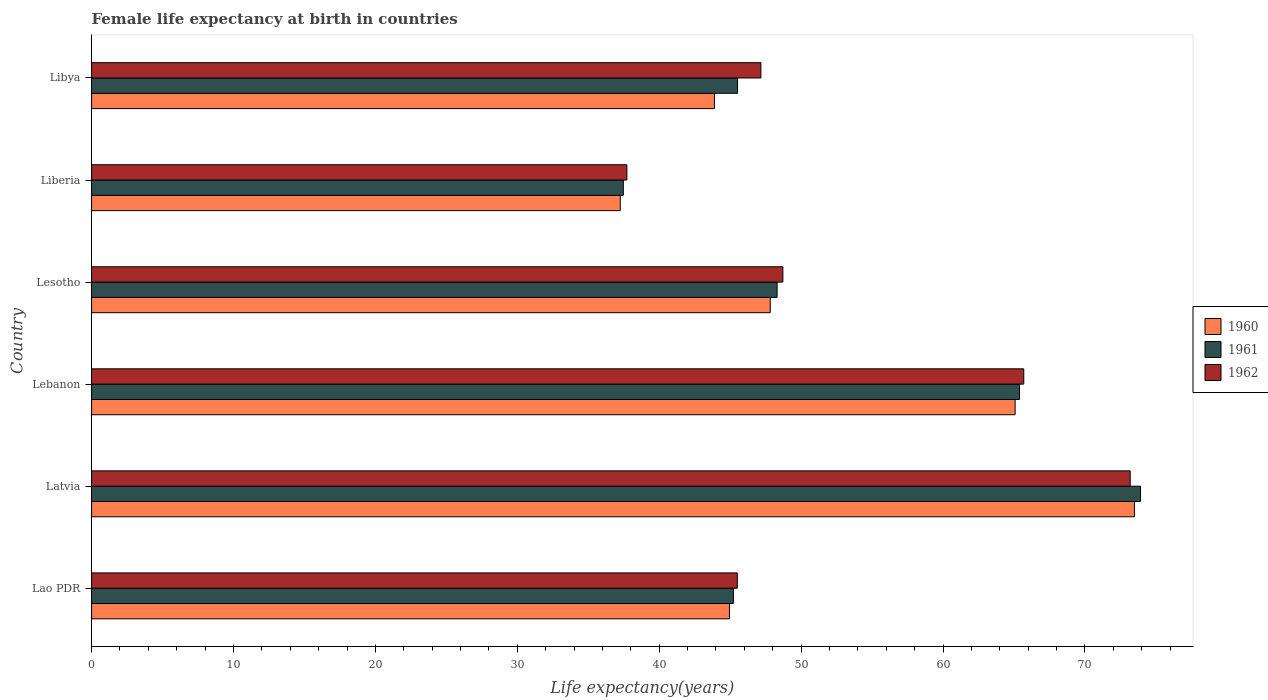Are the number of bars per tick equal to the number of legend labels?
Ensure brevity in your answer.  Yes. How many bars are there on the 3rd tick from the top?
Your answer should be very brief. 3. What is the label of the 1st group of bars from the top?
Offer a terse response. Libya. In how many cases, is the number of bars for a given country not equal to the number of legend labels?
Your answer should be compact. 0. What is the female life expectancy at birth in 1960 in Liberia?
Your answer should be compact. 37.25. Across all countries, what is the maximum female life expectancy at birth in 1960?
Offer a very short reply. 73.49. Across all countries, what is the minimum female life expectancy at birth in 1961?
Provide a succinct answer. 37.47. In which country was the female life expectancy at birth in 1962 maximum?
Provide a succinct answer. Latvia. In which country was the female life expectancy at birth in 1961 minimum?
Keep it short and to the point. Liberia. What is the total female life expectancy at birth in 1962 in the graph?
Ensure brevity in your answer.  317.99. What is the difference between the female life expectancy at birth in 1960 in Latvia and that in Lesotho?
Ensure brevity in your answer.  25.66. What is the difference between the female life expectancy at birth in 1962 in Lesotho and the female life expectancy at birth in 1961 in Lebanon?
Give a very brief answer. -16.68. What is the average female life expectancy at birth in 1962 per country?
Provide a succinct answer. 53. What is the difference between the female life expectancy at birth in 1960 and female life expectancy at birth in 1962 in Lao PDR?
Make the answer very short. -0.55. What is the ratio of the female life expectancy at birth in 1960 in Lao PDR to that in Latvia?
Make the answer very short. 0.61. Is the difference between the female life expectancy at birth in 1960 in Lebanon and Liberia greater than the difference between the female life expectancy at birth in 1962 in Lebanon and Liberia?
Provide a short and direct response. No. What is the difference between the highest and the lowest female life expectancy at birth in 1960?
Provide a short and direct response. 36.24. What does the 2nd bar from the bottom in Lao PDR represents?
Offer a very short reply. 1961. Is it the case that in every country, the sum of the female life expectancy at birth in 1962 and female life expectancy at birth in 1961 is greater than the female life expectancy at birth in 1960?
Give a very brief answer. Yes. How many bars are there?
Your answer should be very brief. 18. What is the difference between two consecutive major ticks on the X-axis?
Offer a very short reply. 10. Are the values on the major ticks of X-axis written in scientific E-notation?
Your answer should be compact. No. Does the graph contain any zero values?
Offer a very short reply. No. How are the legend labels stacked?
Offer a very short reply. Vertical. What is the title of the graph?
Provide a succinct answer. Female life expectancy at birth in countries. What is the label or title of the X-axis?
Offer a terse response. Life expectancy(years). What is the label or title of the Y-axis?
Offer a very short reply. Country. What is the Life expectancy(years) of 1960 in Lao PDR?
Ensure brevity in your answer.  44.95. What is the Life expectancy(years) of 1961 in Lao PDR?
Make the answer very short. 45.23. What is the Life expectancy(years) of 1962 in Lao PDR?
Give a very brief answer. 45.5. What is the Life expectancy(years) of 1960 in Latvia?
Provide a short and direct response. 73.49. What is the Life expectancy(years) of 1961 in Latvia?
Offer a terse response. 73.92. What is the Life expectancy(years) of 1962 in Latvia?
Make the answer very short. 73.19. What is the Life expectancy(years) of 1960 in Lebanon?
Offer a very short reply. 65.08. What is the Life expectancy(years) in 1961 in Lebanon?
Your answer should be very brief. 65.39. What is the Life expectancy(years) of 1962 in Lebanon?
Your response must be concise. 65.69. What is the Life expectancy(years) of 1960 in Lesotho?
Your answer should be compact. 47.83. What is the Life expectancy(years) in 1961 in Lesotho?
Make the answer very short. 48.31. What is the Life expectancy(years) in 1962 in Lesotho?
Give a very brief answer. 48.72. What is the Life expectancy(years) of 1960 in Liberia?
Make the answer very short. 37.25. What is the Life expectancy(years) of 1961 in Liberia?
Make the answer very short. 37.47. What is the Life expectancy(years) of 1962 in Liberia?
Ensure brevity in your answer.  37.72. What is the Life expectancy(years) of 1960 in Libya?
Your response must be concise. 43.89. What is the Life expectancy(years) of 1961 in Libya?
Ensure brevity in your answer.  45.52. What is the Life expectancy(years) of 1962 in Libya?
Give a very brief answer. 47.16. Across all countries, what is the maximum Life expectancy(years) of 1960?
Give a very brief answer. 73.49. Across all countries, what is the maximum Life expectancy(years) in 1961?
Make the answer very short. 73.92. Across all countries, what is the maximum Life expectancy(years) in 1962?
Your answer should be very brief. 73.19. Across all countries, what is the minimum Life expectancy(years) in 1960?
Ensure brevity in your answer.  37.25. Across all countries, what is the minimum Life expectancy(years) in 1961?
Offer a terse response. 37.47. Across all countries, what is the minimum Life expectancy(years) of 1962?
Your response must be concise. 37.72. What is the total Life expectancy(years) in 1960 in the graph?
Give a very brief answer. 312.49. What is the total Life expectancy(years) of 1961 in the graph?
Ensure brevity in your answer.  315.84. What is the total Life expectancy(years) of 1962 in the graph?
Provide a succinct answer. 317.99. What is the difference between the Life expectancy(years) of 1960 in Lao PDR and that in Latvia?
Provide a succinct answer. -28.54. What is the difference between the Life expectancy(years) in 1961 in Lao PDR and that in Latvia?
Give a very brief answer. -28.69. What is the difference between the Life expectancy(years) in 1962 in Lao PDR and that in Latvia?
Your answer should be compact. -27.69. What is the difference between the Life expectancy(years) in 1960 in Lao PDR and that in Lebanon?
Provide a short and direct response. -20.13. What is the difference between the Life expectancy(years) in 1961 in Lao PDR and that in Lebanon?
Your answer should be compact. -20.17. What is the difference between the Life expectancy(years) in 1962 in Lao PDR and that in Lebanon?
Offer a terse response. -20.19. What is the difference between the Life expectancy(years) in 1960 in Lao PDR and that in Lesotho?
Make the answer very short. -2.88. What is the difference between the Life expectancy(years) of 1961 in Lao PDR and that in Lesotho?
Make the answer very short. -3.08. What is the difference between the Life expectancy(years) of 1962 in Lao PDR and that in Lesotho?
Offer a terse response. -3.21. What is the difference between the Life expectancy(years) of 1960 in Lao PDR and that in Liberia?
Your answer should be very brief. 7.7. What is the difference between the Life expectancy(years) of 1961 in Lao PDR and that in Liberia?
Offer a terse response. 7.76. What is the difference between the Life expectancy(years) of 1962 in Lao PDR and that in Liberia?
Ensure brevity in your answer.  7.78. What is the difference between the Life expectancy(years) of 1960 in Lao PDR and that in Libya?
Provide a short and direct response. 1.06. What is the difference between the Life expectancy(years) in 1961 in Lao PDR and that in Libya?
Your answer should be very brief. -0.29. What is the difference between the Life expectancy(years) in 1962 in Lao PDR and that in Libya?
Provide a short and direct response. -1.66. What is the difference between the Life expectancy(years) in 1960 in Latvia and that in Lebanon?
Give a very brief answer. 8.41. What is the difference between the Life expectancy(years) of 1961 in Latvia and that in Lebanon?
Offer a very short reply. 8.53. What is the difference between the Life expectancy(years) of 1960 in Latvia and that in Lesotho?
Your response must be concise. 25.66. What is the difference between the Life expectancy(years) of 1961 in Latvia and that in Lesotho?
Provide a short and direct response. 25.61. What is the difference between the Life expectancy(years) of 1962 in Latvia and that in Lesotho?
Ensure brevity in your answer.  24.48. What is the difference between the Life expectancy(years) of 1960 in Latvia and that in Liberia?
Offer a very short reply. 36.24. What is the difference between the Life expectancy(years) of 1961 in Latvia and that in Liberia?
Ensure brevity in your answer.  36.45. What is the difference between the Life expectancy(years) in 1962 in Latvia and that in Liberia?
Your answer should be compact. 35.47. What is the difference between the Life expectancy(years) of 1960 in Latvia and that in Libya?
Your response must be concise. 29.6. What is the difference between the Life expectancy(years) in 1961 in Latvia and that in Libya?
Make the answer very short. 28.4. What is the difference between the Life expectancy(years) of 1962 in Latvia and that in Libya?
Your answer should be very brief. 26.02. What is the difference between the Life expectancy(years) of 1960 in Lebanon and that in Lesotho?
Provide a succinct answer. 17.26. What is the difference between the Life expectancy(years) in 1961 in Lebanon and that in Lesotho?
Your answer should be compact. 17.09. What is the difference between the Life expectancy(years) of 1962 in Lebanon and that in Lesotho?
Offer a very short reply. 16.98. What is the difference between the Life expectancy(years) in 1960 in Lebanon and that in Liberia?
Provide a short and direct response. 27.83. What is the difference between the Life expectancy(years) in 1961 in Lebanon and that in Liberia?
Keep it short and to the point. 27.92. What is the difference between the Life expectancy(years) of 1962 in Lebanon and that in Liberia?
Your answer should be very brief. 27.97. What is the difference between the Life expectancy(years) in 1960 in Lebanon and that in Libya?
Provide a succinct answer. 21.19. What is the difference between the Life expectancy(years) of 1961 in Lebanon and that in Libya?
Offer a very short reply. 19.87. What is the difference between the Life expectancy(years) in 1962 in Lebanon and that in Libya?
Your response must be concise. 18.52. What is the difference between the Life expectancy(years) in 1960 in Lesotho and that in Liberia?
Ensure brevity in your answer.  10.57. What is the difference between the Life expectancy(years) in 1961 in Lesotho and that in Liberia?
Give a very brief answer. 10.84. What is the difference between the Life expectancy(years) in 1962 in Lesotho and that in Liberia?
Give a very brief answer. 10.99. What is the difference between the Life expectancy(years) in 1960 in Lesotho and that in Libya?
Offer a terse response. 3.93. What is the difference between the Life expectancy(years) of 1961 in Lesotho and that in Libya?
Offer a very short reply. 2.79. What is the difference between the Life expectancy(years) of 1962 in Lesotho and that in Libya?
Your answer should be compact. 1.55. What is the difference between the Life expectancy(years) of 1960 in Liberia and that in Libya?
Offer a terse response. -6.64. What is the difference between the Life expectancy(years) of 1961 in Liberia and that in Libya?
Provide a succinct answer. -8.05. What is the difference between the Life expectancy(years) in 1962 in Liberia and that in Libya?
Your answer should be very brief. -9.44. What is the difference between the Life expectancy(years) in 1960 in Lao PDR and the Life expectancy(years) in 1961 in Latvia?
Offer a terse response. -28.97. What is the difference between the Life expectancy(years) in 1960 in Lao PDR and the Life expectancy(years) in 1962 in Latvia?
Offer a very short reply. -28.24. What is the difference between the Life expectancy(years) in 1961 in Lao PDR and the Life expectancy(years) in 1962 in Latvia?
Keep it short and to the point. -27.96. What is the difference between the Life expectancy(years) of 1960 in Lao PDR and the Life expectancy(years) of 1961 in Lebanon?
Offer a very short reply. -20.44. What is the difference between the Life expectancy(years) in 1960 in Lao PDR and the Life expectancy(years) in 1962 in Lebanon?
Give a very brief answer. -20.74. What is the difference between the Life expectancy(years) in 1961 in Lao PDR and the Life expectancy(years) in 1962 in Lebanon?
Your response must be concise. -20.46. What is the difference between the Life expectancy(years) of 1960 in Lao PDR and the Life expectancy(years) of 1961 in Lesotho?
Your response must be concise. -3.36. What is the difference between the Life expectancy(years) of 1960 in Lao PDR and the Life expectancy(years) of 1962 in Lesotho?
Offer a very short reply. -3.77. What is the difference between the Life expectancy(years) in 1961 in Lao PDR and the Life expectancy(years) in 1962 in Lesotho?
Keep it short and to the point. -3.49. What is the difference between the Life expectancy(years) in 1960 in Lao PDR and the Life expectancy(years) in 1961 in Liberia?
Offer a terse response. 7.48. What is the difference between the Life expectancy(years) of 1960 in Lao PDR and the Life expectancy(years) of 1962 in Liberia?
Ensure brevity in your answer.  7.23. What is the difference between the Life expectancy(years) of 1961 in Lao PDR and the Life expectancy(years) of 1962 in Liberia?
Offer a terse response. 7.5. What is the difference between the Life expectancy(years) of 1960 in Lao PDR and the Life expectancy(years) of 1961 in Libya?
Your answer should be compact. -0.57. What is the difference between the Life expectancy(years) in 1960 in Lao PDR and the Life expectancy(years) in 1962 in Libya?
Your answer should be very brief. -2.22. What is the difference between the Life expectancy(years) of 1961 in Lao PDR and the Life expectancy(years) of 1962 in Libya?
Make the answer very short. -1.94. What is the difference between the Life expectancy(years) of 1960 in Latvia and the Life expectancy(years) of 1961 in Lebanon?
Your answer should be very brief. 8.1. What is the difference between the Life expectancy(years) in 1961 in Latvia and the Life expectancy(years) in 1962 in Lebanon?
Offer a terse response. 8.23. What is the difference between the Life expectancy(years) in 1960 in Latvia and the Life expectancy(years) in 1961 in Lesotho?
Offer a terse response. 25.18. What is the difference between the Life expectancy(years) in 1960 in Latvia and the Life expectancy(years) in 1962 in Lesotho?
Ensure brevity in your answer.  24.77. What is the difference between the Life expectancy(years) in 1961 in Latvia and the Life expectancy(years) in 1962 in Lesotho?
Make the answer very short. 25.2. What is the difference between the Life expectancy(years) of 1960 in Latvia and the Life expectancy(years) of 1961 in Liberia?
Keep it short and to the point. 36.02. What is the difference between the Life expectancy(years) in 1960 in Latvia and the Life expectancy(years) in 1962 in Liberia?
Give a very brief answer. 35.77. What is the difference between the Life expectancy(years) of 1961 in Latvia and the Life expectancy(years) of 1962 in Liberia?
Keep it short and to the point. 36.2. What is the difference between the Life expectancy(years) in 1960 in Latvia and the Life expectancy(years) in 1961 in Libya?
Provide a succinct answer. 27.97. What is the difference between the Life expectancy(years) in 1960 in Latvia and the Life expectancy(years) in 1962 in Libya?
Offer a very short reply. 26.32. What is the difference between the Life expectancy(years) in 1961 in Latvia and the Life expectancy(years) in 1962 in Libya?
Offer a very short reply. 26.75. What is the difference between the Life expectancy(years) in 1960 in Lebanon and the Life expectancy(years) in 1961 in Lesotho?
Your answer should be very brief. 16.77. What is the difference between the Life expectancy(years) in 1960 in Lebanon and the Life expectancy(years) in 1962 in Lesotho?
Provide a short and direct response. 16.37. What is the difference between the Life expectancy(years) in 1961 in Lebanon and the Life expectancy(years) in 1962 in Lesotho?
Your answer should be compact. 16.68. What is the difference between the Life expectancy(years) in 1960 in Lebanon and the Life expectancy(years) in 1961 in Liberia?
Provide a succinct answer. 27.61. What is the difference between the Life expectancy(years) of 1960 in Lebanon and the Life expectancy(years) of 1962 in Liberia?
Your answer should be compact. 27.36. What is the difference between the Life expectancy(years) in 1961 in Lebanon and the Life expectancy(years) in 1962 in Liberia?
Your answer should be very brief. 27.67. What is the difference between the Life expectancy(years) in 1960 in Lebanon and the Life expectancy(years) in 1961 in Libya?
Offer a terse response. 19.56. What is the difference between the Life expectancy(years) in 1960 in Lebanon and the Life expectancy(years) in 1962 in Libya?
Provide a succinct answer. 17.92. What is the difference between the Life expectancy(years) in 1961 in Lebanon and the Life expectancy(years) in 1962 in Libya?
Ensure brevity in your answer.  18.23. What is the difference between the Life expectancy(years) in 1960 in Lesotho and the Life expectancy(years) in 1961 in Liberia?
Your answer should be very brief. 10.35. What is the difference between the Life expectancy(years) in 1960 in Lesotho and the Life expectancy(years) in 1962 in Liberia?
Provide a short and direct response. 10.1. What is the difference between the Life expectancy(years) in 1961 in Lesotho and the Life expectancy(years) in 1962 in Liberia?
Offer a terse response. 10.59. What is the difference between the Life expectancy(years) in 1960 in Lesotho and the Life expectancy(years) in 1961 in Libya?
Give a very brief answer. 2.31. What is the difference between the Life expectancy(years) in 1960 in Lesotho and the Life expectancy(years) in 1962 in Libya?
Your answer should be compact. 0.66. What is the difference between the Life expectancy(years) of 1961 in Lesotho and the Life expectancy(years) of 1962 in Libya?
Ensure brevity in your answer.  1.14. What is the difference between the Life expectancy(years) of 1960 in Liberia and the Life expectancy(years) of 1961 in Libya?
Your answer should be compact. -8.27. What is the difference between the Life expectancy(years) of 1960 in Liberia and the Life expectancy(years) of 1962 in Libya?
Offer a very short reply. -9.91. What is the difference between the Life expectancy(years) of 1961 in Liberia and the Life expectancy(years) of 1962 in Libya?
Your answer should be compact. -9.69. What is the average Life expectancy(years) of 1960 per country?
Your response must be concise. 52.08. What is the average Life expectancy(years) of 1961 per country?
Your answer should be very brief. 52.64. What is the average Life expectancy(years) of 1962 per country?
Provide a short and direct response. 53. What is the difference between the Life expectancy(years) of 1960 and Life expectancy(years) of 1961 in Lao PDR?
Offer a very short reply. -0.28. What is the difference between the Life expectancy(years) of 1960 and Life expectancy(years) of 1962 in Lao PDR?
Offer a terse response. -0.55. What is the difference between the Life expectancy(years) of 1961 and Life expectancy(years) of 1962 in Lao PDR?
Give a very brief answer. -0.28. What is the difference between the Life expectancy(years) in 1960 and Life expectancy(years) in 1961 in Latvia?
Your response must be concise. -0.43. What is the difference between the Life expectancy(years) in 1961 and Life expectancy(years) in 1962 in Latvia?
Give a very brief answer. 0.73. What is the difference between the Life expectancy(years) in 1960 and Life expectancy(years) in 1961 in Lebanon?
Your response must be concise. -0.31. What is the difference between the Life expectancy(years) of 1960 and Life expectancy(years) of 1962 in Lebanon?
Offer a very short reply. -0.61. What is the difference between the Life expectancy(years) in 1961 and Life expectancy(years) in 1962 in Lebanon?
Provide a succinct answer. -0.3. What is the difference between the Life expectancy(years) in 1960 and Life expectancy(years) in 1961 in Lesotho?
Make the answer very short. -0.48. What is the difference between the Life expectancy(years) of 1960 and Life expectancy(years) of 1962 in Lesotho?
Provide a short and direct response. -0.89. What is the difference between the Life expectancy(years) of 1961 and Life expectancy(years) of 1962 in Lesotho?
Provide a succinct answer. -0.41. What is the difference between the Life expectancy(years) of 1960 and Life expectancy(years) of 1961 in Liberia?
Make the answer very short. -0.22. What is the difference between the Life expectancy(years) in 1960 and Life expectancy(years) in 1962 in Liberia?
Your response must be concise. -0.47. What is the difference between the Life expectancy(years) of 1961 and Life expectancy(years) of 1962 in Liberia?
Provide a succinct answer. -0.25. What is the difference between the Life expectancy(years) of 1960 and Life expectancy(years) of 1961 in Libya?
Give a very brief answer. -1.63. What is the difference between the Life expectancy(years) of 1960 and Life expectancy(years) of 1962 in Libya?
Provide a short and direct response. -3.27. What is the difference between the Life expectancy(years) in 1961 and Life expectancy(years) in 1962 in Libya?
Your response must be concise. -1.65. What is the ratio of the Life expectancy(years) of 1960 in Lao PDR to that in Latvia?
Keep it short and to the point. 0.61. What is the ratio of the Life expectancy(years) in 1961 in Lao PDR to that in Latvia?
Make the answer very short. 0.61. What is the ratio of the Life expectancy(years) of 1962 in Lao PDR to that in Latvia?
Offer a terse response. 0.62. What is the ratio of the Life expectancy(years) of 1960 in Lao PDR to that in Lebanon?
Provide a succinct answer. 0.69. What is the ratio of the Life expectancy(years) of 1961 in Lao PDR to that in Lebanon?
Provide a short and direct response. 0.69. What is the ratio of the Life expectancy(years) of 1962 in Lao PDR to that in Lebanon?
Ensure brevity in your answer.  0.69. What is the ratio of the Life expectancy(years) of 1960 in Lao PDR to that in Lesotho?
Make the answer very short. 0.94. What is the ratio of the Life expectancy(years) of 1961 in Lao PDR to that in Lesotho?
Keep it short and to the point. 0.94. What is the ratio of the Life expectancy(years) of 1962 in Lao PDR to that in Lesotho?
Provide a short and direct response. 0.93. What is the ratio of the Life expectancy(years) in 1960 in Lao PDR to that in Liberia?
Your answer should be very brief. 1.21. What is the ratio of the Life expectancy(years) of 1961 in Lao PDR to that in Liberia?
Provide a succinct answer. 1.21. What is the ratio of the Life expectancy(years) in 1962 in Lao PDR to that in Liberia?
Your response must be concise. 1.21. What is the ratio of the Life expectancy(years) in 1960 in Lao PDR to that in Libya?
Keep it short and to the point. 1.02. What is the ratio of the Life expectancy(years) in 1961 in Lao PDR to that in Libya?
Keep it short and to the point. 0.99. What is the ratio of the Life expectancy(years) of 1962 in Lao PDR to that in Libya?
Ensure brevity in your answer.  0.96. What is the ratio of the Life expectancy(years) of 1960 in Latvia to that in Lebanon?
Give a very brief answer. 1.13. What is the ratio of the Life expectancy(years) of 1961 in Latvia to that in Lebanon?
Provide a short and direct response. 1.13. What is the ratio of the Life expectancy(years) in 1962 in Latvia to that in Lebanon?
Offer a terse response. 1.11. What is the ratio of the Life expectancy(years) of 1960 in Latvia to that in Lesotho?
Keep it short and to the point. 1.54. What is the ratio of the Life expectancy(years) in 1961 in Latvia to that in Lesotho?
Your answer should be compact. 1.53. What is the ratio of the Life expectancy(years) in 1962 in Latvia to that in Lesotho?
Your response must be concise. 1.5. What is the ratio of the Life expectancy(years) of 1960 in Latvia to that in Liberia?
Ensure brevity in your answer.  1.97. What is the ratio of the Life expectancy(years) of 1961 in Latvia to that in Liberia?
Offer a very short reply. 1.97. What is the ratio of the Life expectancy(years) in 1962 in Latvia to that in Liberia?
Give a very brief answer. 1.94. What is the ratio of the Life expectancy(years) of 1960 in Latvia to that in Libya?
Provide a short and direct response. 1.67. What is the ratio of the Life expectancy(years) of 1961 in Latvia to that in Libya?
Provide a short and direct response. 1.62. What is the ratio of the Life expectancy(years) in 1962 in Latvia to that in Libya?
Provide a short and direct response. 1.55. What is the ratio of the Life expectancy(years) in 1960 in Lebanon to that in Lesotho?
Ensure brevity in your answer.  1.36. What is the ratio of the Life expectancy(years) of 1961 in Lebanon to that in Lesotho?
Your answer should be compact. 1.35. What is the ratio of the Life expectancy(years) in 1962 in Lebanon to that in Lesotho?
Make the answer very short. 1.35. What is the ratio of the Life expectancy(years) in 1960 in Lebanon to that in Liberia?
Keep it short and to the point. 1.75. What is the ratio of the Life expectancy(years) in 1961 in Lebanon to that in Liberia?
Make the answer very short. 1.75. What is the ratio of the Life expectancy(years) of 1962 in Lebanon to that in Liberia?
Provide a short and direct response. 1.74. What is the ratio of the Life expectancy(years) of 1960 in Lebanon to that in Libya?
Give a very brief answer. 1.48. What is the ratio of the Life expectancy(years) in 1961 in Lebanon to that in Libya?
Keep it short and to the point. 1.44. What is the ratio of the Life expectancy(years) of 1962 in Lebanon to that in Libya?
Provide a short and direct response. 1.39. What is the ratio of the Life expectancy(years) in 1960 in Lesotho to that in Liberia?
Offer a terse response. 1.28. What is the ratio of the Life expectancy(years) of 1961 in Lesotho to that in Liberia?
Your answer should be very brief. 1.29. What is the ratio of the Life expectancy(years) of 1962 in Lesotho to that in Liberia?
Your answer should be compact. 1.29. What is the ratio of the Life expectancy(years) in 1960 in Lesotho to that in Libya?
Your answer should be compact. 1.09. What is the ratio of the Life expectancy(years) of 1961 in Lesotho to that in Libya?
Your answer should be compact. 1.06. What is the ratio of the Life expectancy(years) of 1962 in Lesotho to that in Libya?
Provide a short and direct response. 1.03. What is the ratio of the Life expectancy(years) in 1960 in Liberia to that in Libya?
Ensure brevity in your answer.  0.85. What is the ratio of the Life expectancy(years) in 1961 in Liberia to that in Libya?
Provide a succinct answer. 0.82. What is the ratio of the Life expectancy(years) of 1962 in Liberia to that in Libya?
Offer a terse response. 0.8. What is the difference between the highest and the second highest Life expectancy(years) in 1960?
Ensure brevity in your answer.  8.41. What is the difference between the highest and the second highest Life expectancy(years) in 1961?
Ensure brevity in your answer.  8.53. What is the difference between the highest and the second highest Life expectancy(years) of 1962?
Make the answer very short. 7.5. What is the difference between the highest and the lowest Life expectancy(years) in 1960?
Ensure brevity in your answer.  36.24. What is the difference between the highest and the lowest Life expectancy(years) of 1961?
Give a very brief answer. 36.45. What is the difference between the highest and the lowest Life expectancy(years) in 1962?
Give a very brief answer. 35.47. 